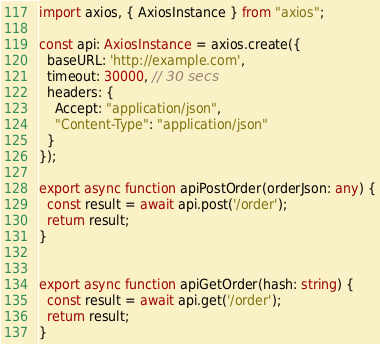Convert code to text. <code><loc_0><loc_0><loc_500><loc_500><_TypeScript_>import axios, { AxiosInstance } from "axios";

const api: AxiosInstance = axios.create({
  baseURL: 'http://example.com',
  timeout: 30000, // 30 secs
  headers: {
    Accept: "application/json",
    "Content-Type": "application/json"
  }
});

export async function apiPostOrder(orderJson: any) {
  const result = await api.post('/order');
  return result;
}


export async function apiGetOrder(hash: string) {
  const result = await api.get('/order');
  return result;
}
</code> 